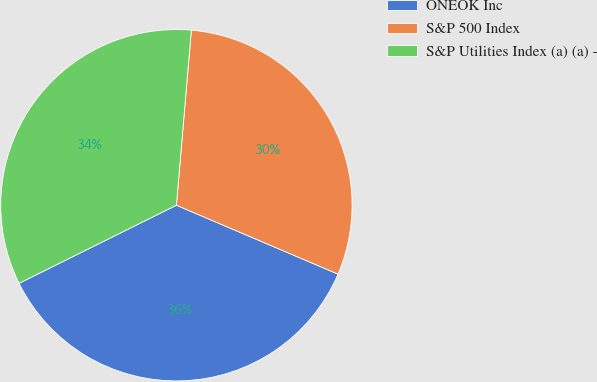Convert chart. <chart><loc_0><loc_0><loc_500><loc_500><pie_chart><fcel>ONEOK Inc<fcel>S&P 500 Index<fcel>S&P Utilities Index (a) (a) -<nl><fcel>36.25%<fcel>30.06%<fcel>33.69%<nl></chart> 